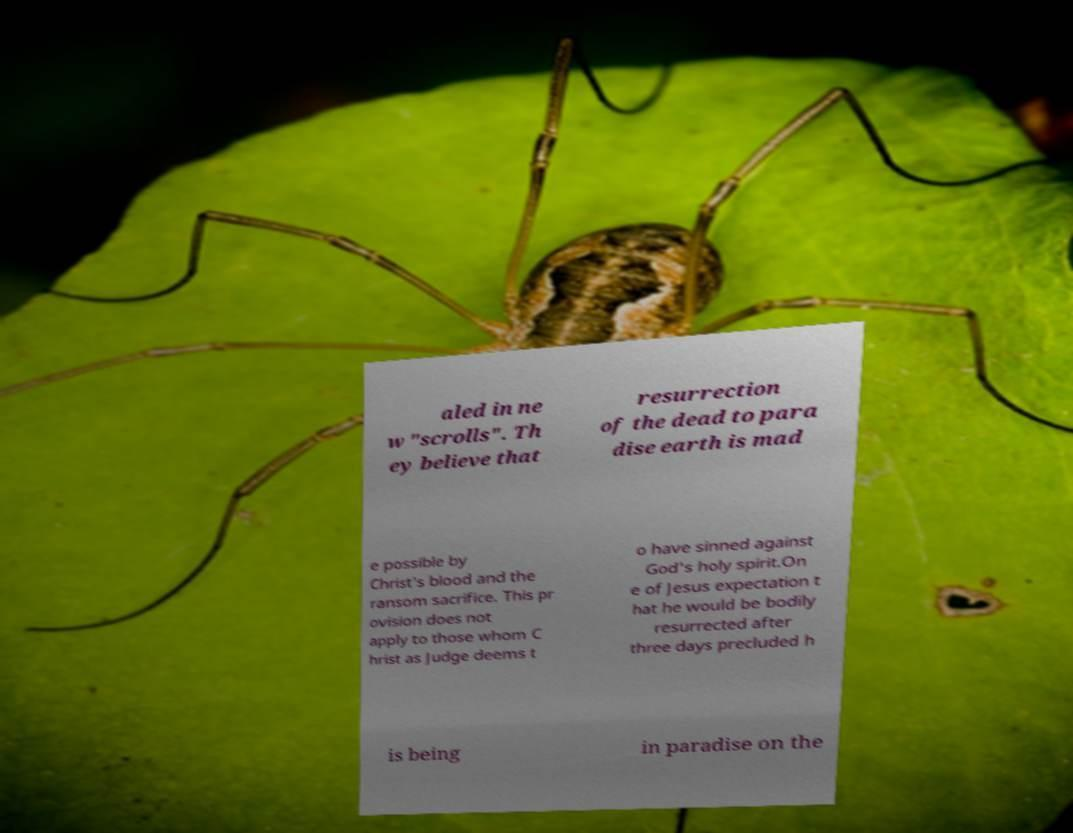Please identify and transcribe the text found in this image. aled in ne w "scrolls". Th ey believe that resurrection of the dead to para dise earth is mad e possible by Christ's blood and the ransom sacrifice. This pr ovision does not apply to those whom C hrist as Judge deems t o have sinned against God's holy spirit.On e of Jesus expectation t hat he would be bodily resurrected after three days precluded h is being in paradise on the 